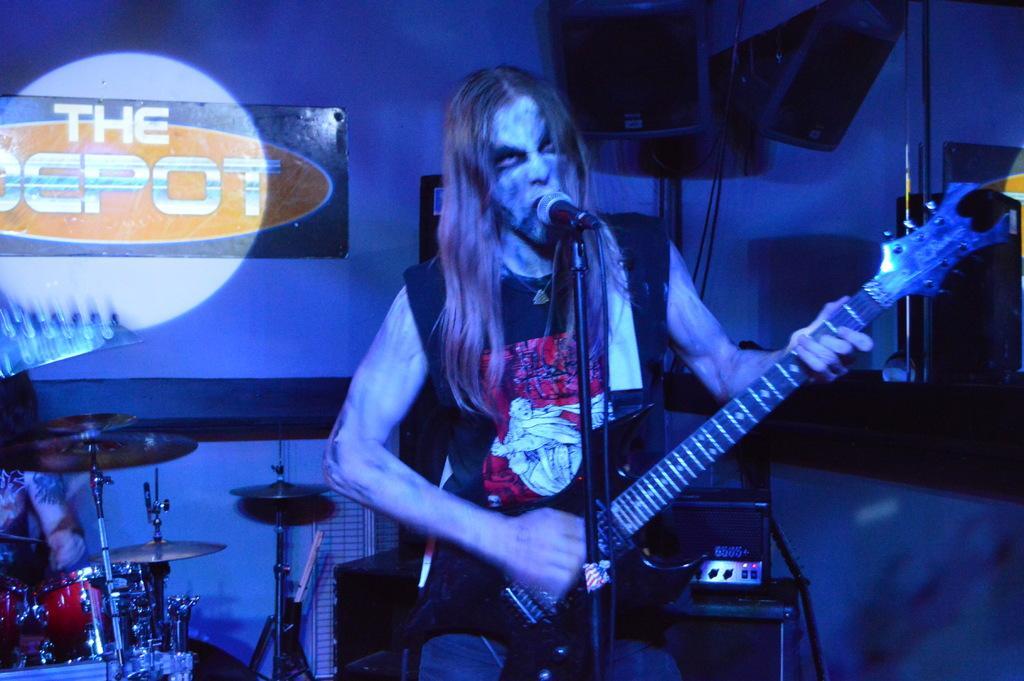How would you summarize this image in a sentence or two? As we can see in the image there is a man singing a song and holding guitar in his hand. On the left side there are musical drums. 